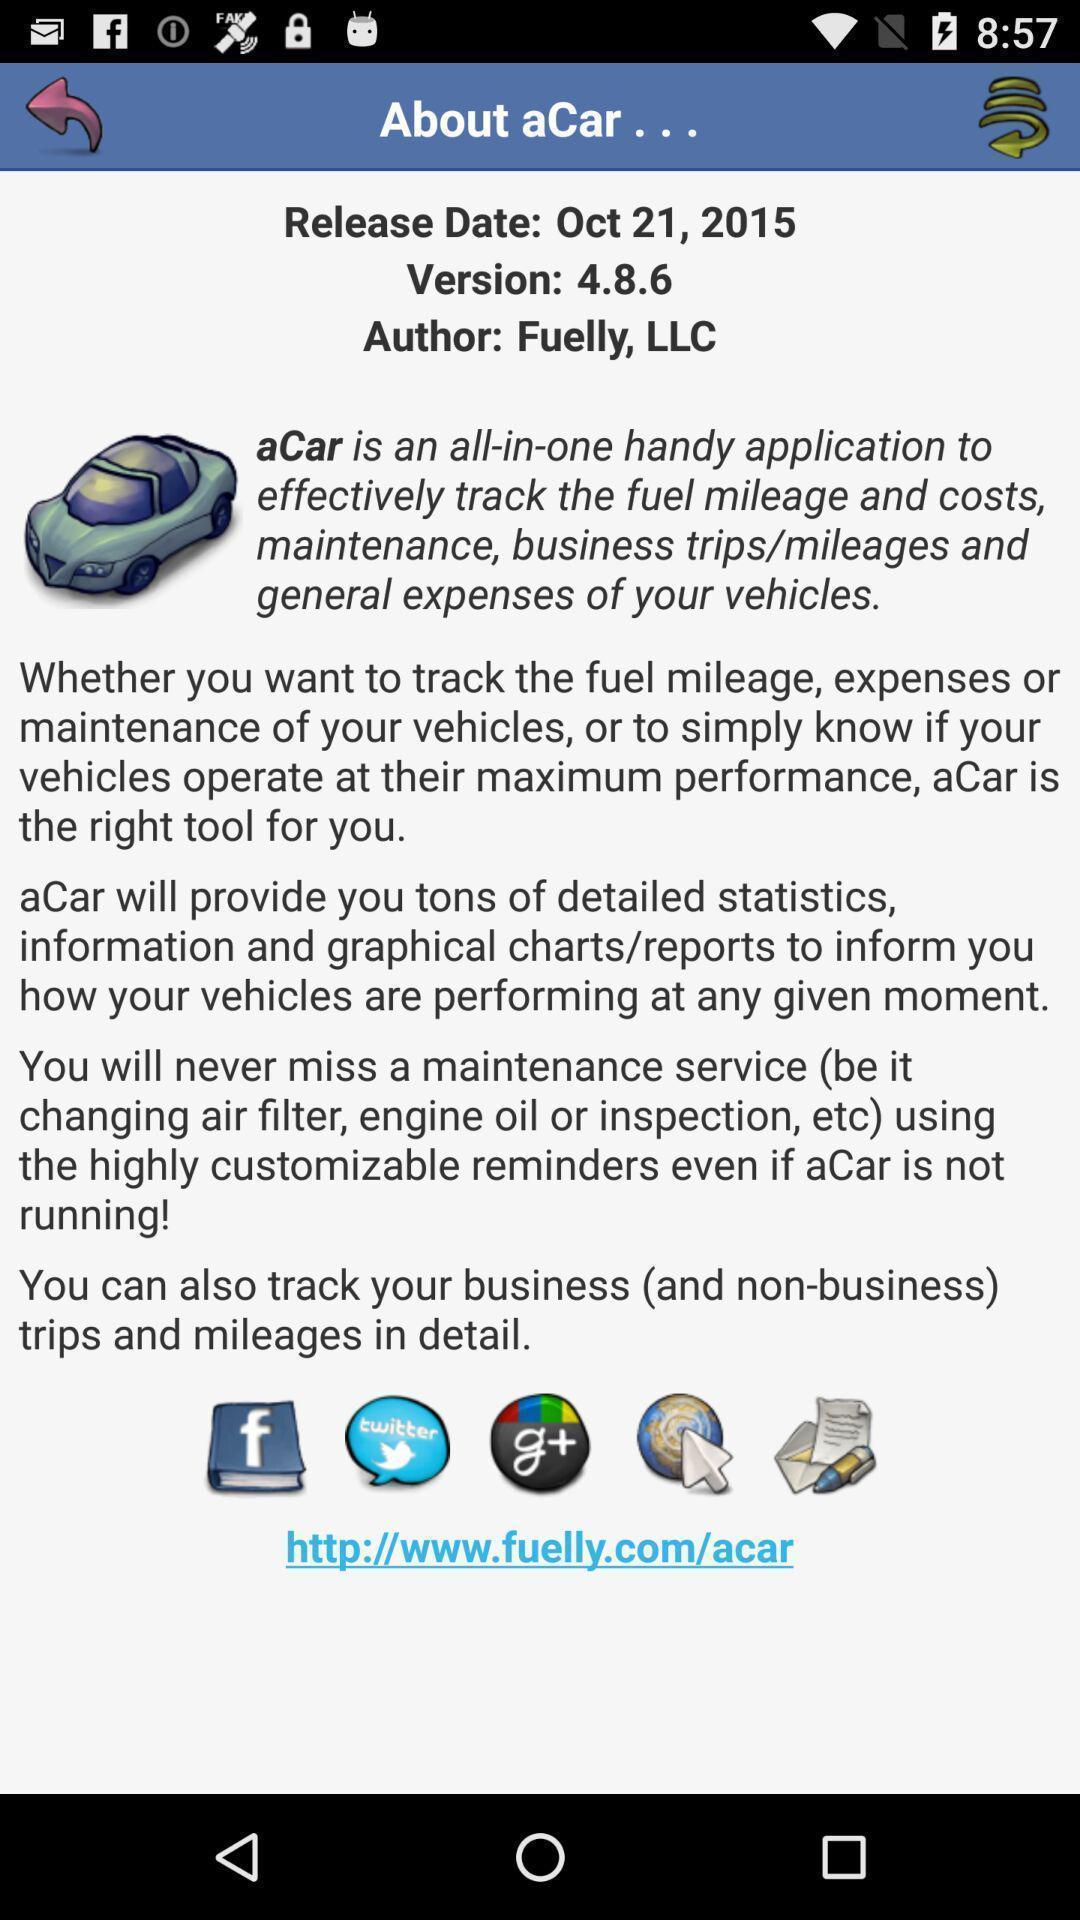What is the overall content of this screenshot? Page showing details about a tracking app. 